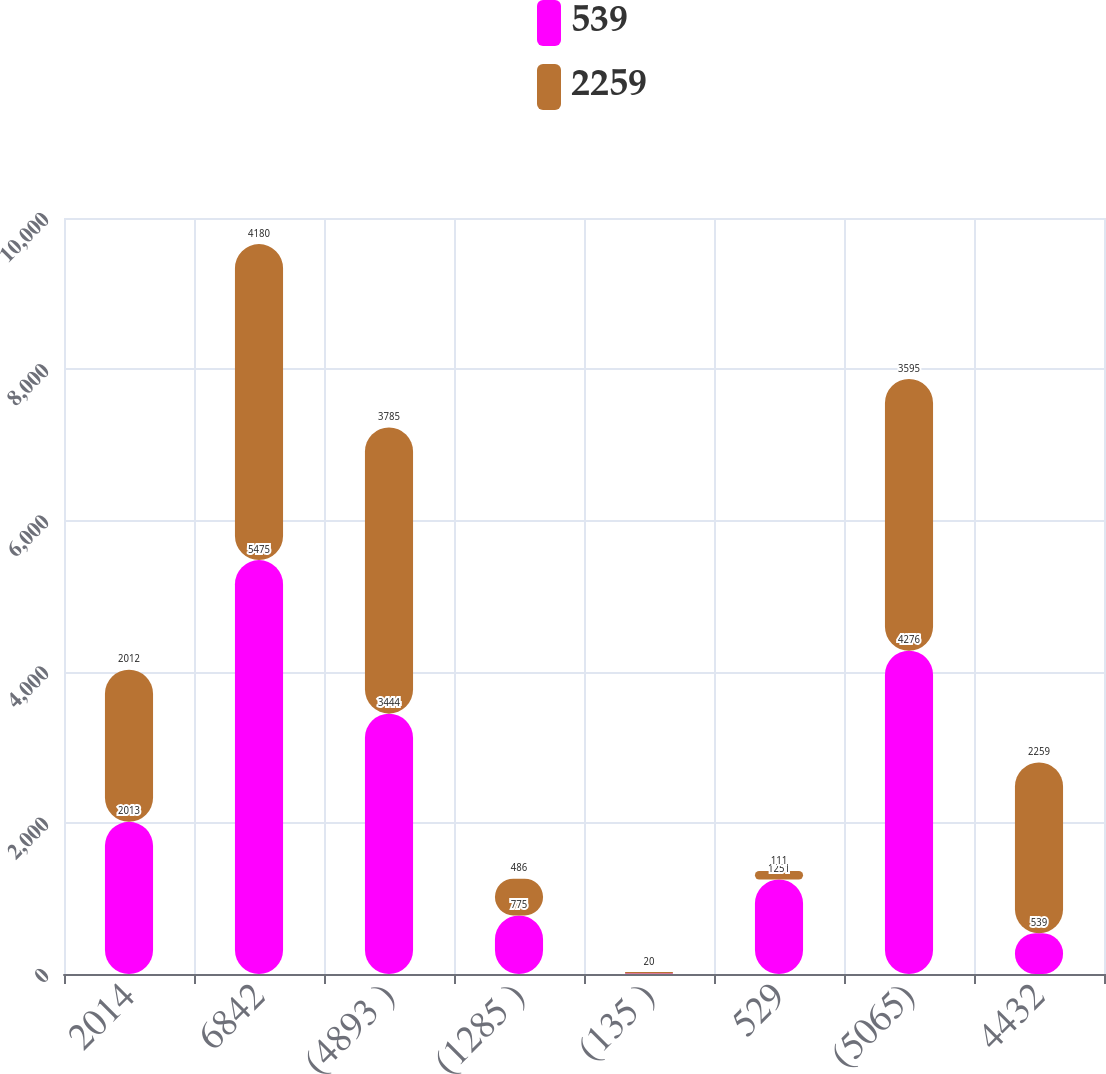Convert chart. <chart><loc_0><loc_0><loc_500><loc_500><stacked_bar_chart><ecel><fcel>2014<fcel>6842<fcel>(4893 )<fcel>(1285 )<fcel>(135 )<fcel>529<fcel>(5065)<fcel>4432<nl><fcel>539<fcel>2013<fcel>5475<fcel>3444<fcel>775<fcel>5<fcel>1251<fcel>4276<fcel>539<nl><fcel>2259<fcel>2012<fcel>4180<fcel>3785<fcel>486<fcel>20<fcel>111<fcel>3595<fcel>2259<nl></chart> 